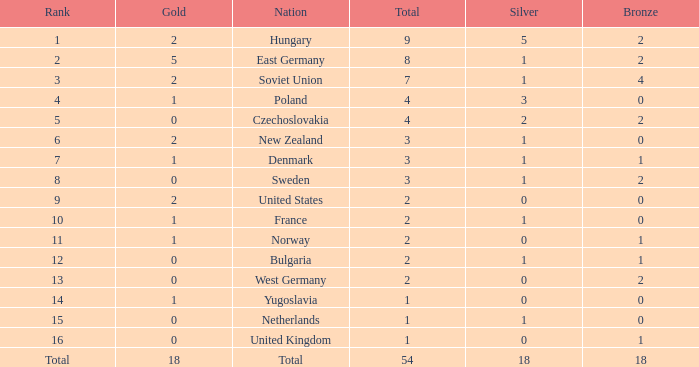What is the lowest total for those receiving less than 18 but more than 14? 1.0. 